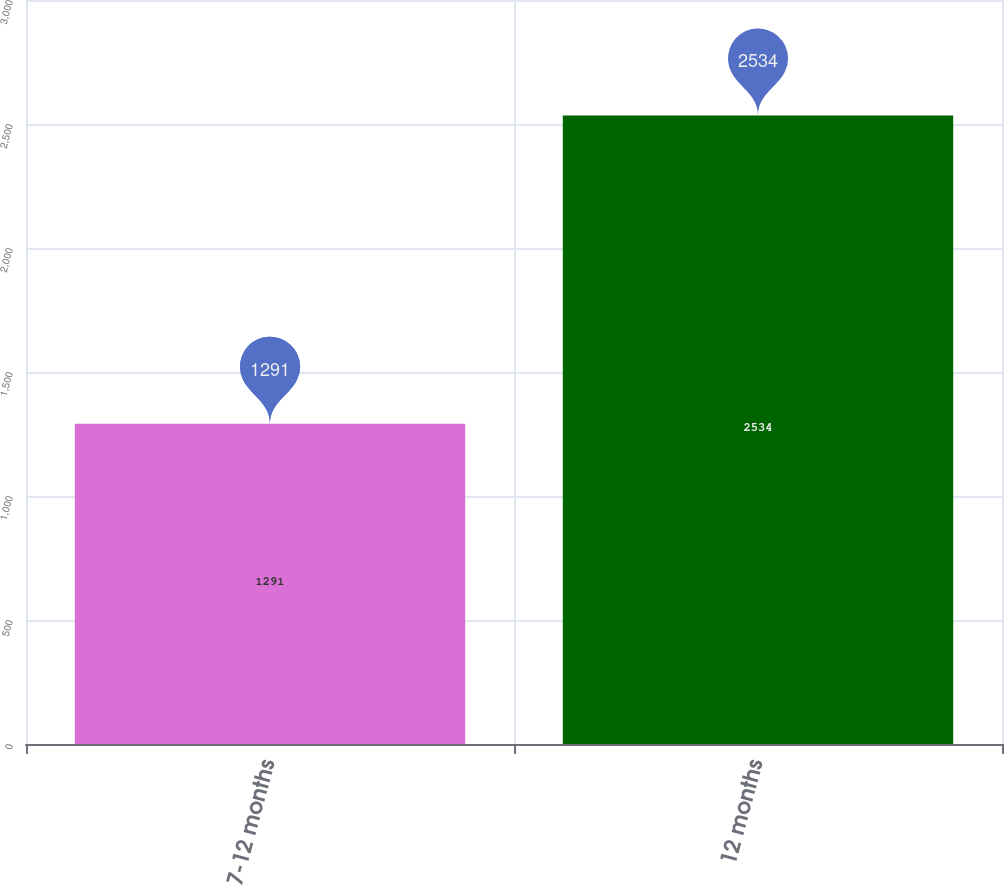Convert chart. <chart><loc_0><loc_0><loc_500><loc_500><bar_chart><fcel>7-12 months<fcel>12 months<nl><fcel>1291<fcel>2534<nl></chart> 